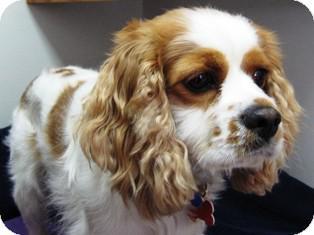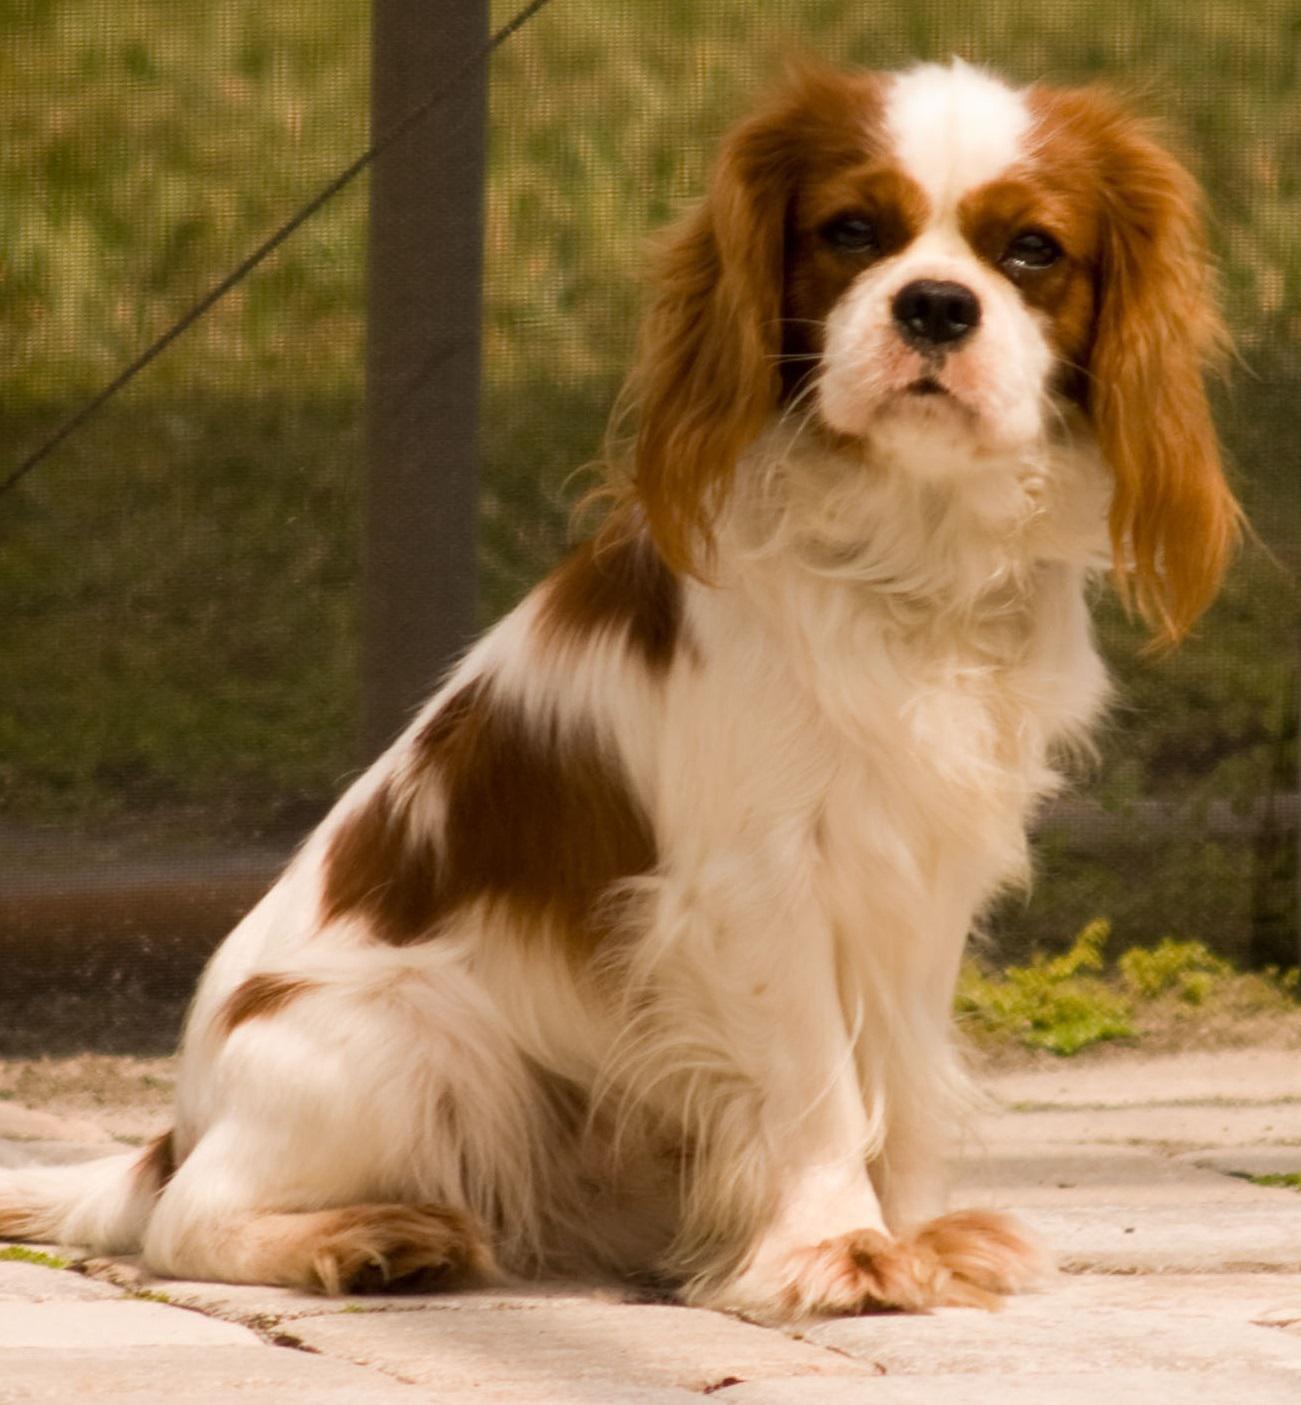The first image is the image on the left, the second image is the image on the right. Analyze the images presented: Is the assertion "The lone dog within the left image is not smiling." valid? Answer yes or no. Yes. The first image is the image on the left, the second image is the image on the right. Examine the images to the left and right. Is the description "At least one image shows a dog with a dog tag." accurate? Answer yes or no. Yes. 